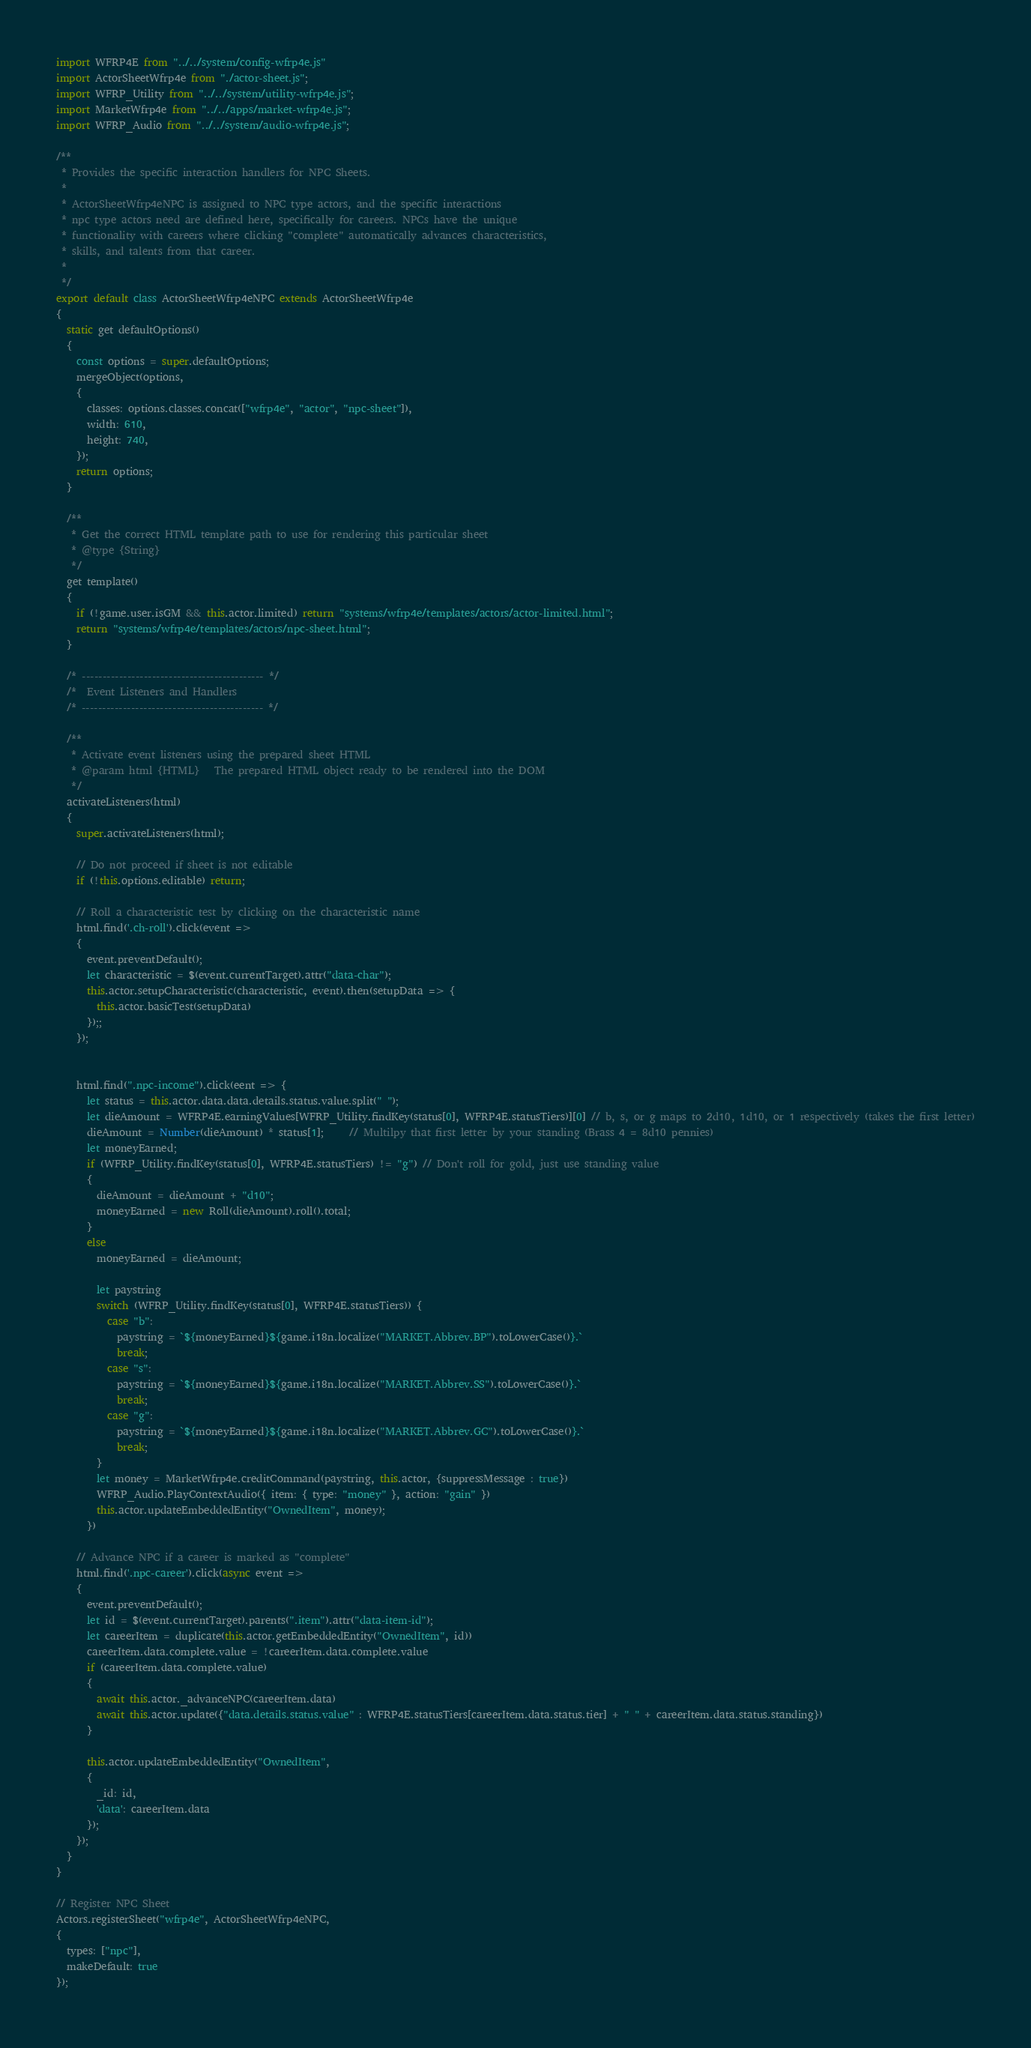Convert code to text. <code><loc_0><loc_0><loc_500><loc_500><_JavaScript_>import WFRP4E from "../../system/config-wfrp4e.js"
import ActorSheetWfrp4e from "./actor-sheet.js";
import WFRP_Utility from "../../system/utility-wfrp4e.js";
import MarketWfrp4e from "../../apps/market-wfrp4e.js";
import WFRP_Audio from "../../system/audio-wfrp4e.js";

/**
 * Provides the specific interaction handlers for NPC Sheets.
 *
 * ActorSheetWfrp4eNPC is assigned to NPC type actors, and the specific interactions
 * npc type actors need are defined here, specifically for careers. NPCs have the unique
 * functionality with careers where clicking "complete" automatically advances characteristics,
 * skills, and talents from that career.
 * 
 */
export default class ActorSheetWfrp4eNPC extends ActorSheetWfrp4e
{
  static get defaultOptions()
  {
    const options = super.defaultOptions;
    mergeObject(options,
    {
      classes: options.classes.concat(["wfrp4e", "actor", "npc-sheet"]),
      width: 610,
      height: 740,
    });
    return options;
  }

  /**
   * Get the correct HTML template path to use for rendering this particular sheet
   * @type {String}
   */
  get template()
  {
    if (!game.user.isGM && this.actor.limited) return "systems/wfrp4e/templates/actors/actor-limited.html";
    return "systems/wfrp4e/templates/actors/npc-sheet.html";
  }

  /* -------------------------------------------- */
  /*  Event Listeners and Handlers
  /* -------------------------------------------- */

  /**
   * Activate event listeners using the prepared sheet HTML
   * @param html {HTML}   The prepared HTML object ready to be rendered into the DOM
   */
  activateListeners(html)
  {
    super.activateListeners(html);

    // Do not proceed if sheet is not editable
    if (!this.options.editable) return;

    // Roll a characteristic test by clicking on the characteristic name
    html.find('.ch-roll').click(event =>
    {
      event.preventDefault();
      let characteristic = $(event.currentTarget).attr("data-char");
      this.actor.setupCharacteristic(characteristic, event).then(setupData => {
        this.actor.basicTest(setupData)
      });;
    });


    html.find(".npc-income").click(eent => {
      let status = this.actor.data.data.details.status.value.split(" ");
      let dieAmount = WFRP4E.earningValues[WFRP_Utility.findKey(status[0], WFRP4E.statusTiers)][0] // b, s, or g maps to 2d10, 1d10, or 1 respectively (takes the first letter)
      dieAmount = Number(dieAmount) * status[1];     // Multilpy that first letter by your standing (Brass 4 = 8d10 pennies)
      let moneyEarned;
      if (WFRP_Utility.findKey(status[0], WFRP4E.statusTiers) != "g") // Don't roll for gold, just use standing value
      {
        dieAmount = dieAmount + "d10";
        moneyEarned = new Roll(dieAmount).roll().total;
      }
      else
        moneyEarned = dieAmount;
      
        let paystring
        switch (WFRP_Utility.findKey(status[0], WFRP4E.statusTiers)) {
          case "b":
            paystring = `${moneyEarned}${game.i18n.localize("MARKET.Abbrev.BP").toLowerCase()}.`
            break;
          case "s":
            paystring = `${moneyEarned}${game.i18n.localize("MARKET.Abbrev.SS").toLowerCase()}.`
            break;
          case "g":
            paystring = `${moneyEarned}${game.i18n.localize("MARKET.Abbrev.GC").toLowerCase()}.`
            break;
        }
        let money = MarketWfrp4e.creditCommand(paystring, this.actor, {suppressMessage : true})
        WFRP_Audio.PlayContextAudio({ item: { type: "money" }, action: "gain" })
        this.actor.updateEmbeddedEntity("OwnedItem", money);
      })

    // Advance NPC if a career is marked as "complete"
    html.find('.npc-career').click(async event =>
    {
      event.preventDefault();
      let id = $(event.currentTarget).parents(".item").attr("data-item-id");
      let careerItem = duplicate(this.actor.getEmbeddedEntity("OwnedItem", id))
      careerItem.data.complete.value = !careerItem.data.complete.value
      if (careerItem.data.complete.value)
      {
        await this.actor._advanceNPC(careerItem.data)
        await this.actor.update({"data.details.status.value" : WFRP4E.statusTiers[careerItem.data.status.tier] + " " + careerItem.data.status.standing})
      }

      this.actor.updateEmbeddedEntity("OwnedItem",
      {
        _id: id,
        'data': careerItem.data
      });
    });
  }
}

// Register NPC Sheet
Actors.registerSheet("wfrp4e", ActorSheetWfrp4eNPC,
{
  types: ["npc"],
  makeDefault: true
});</code> 